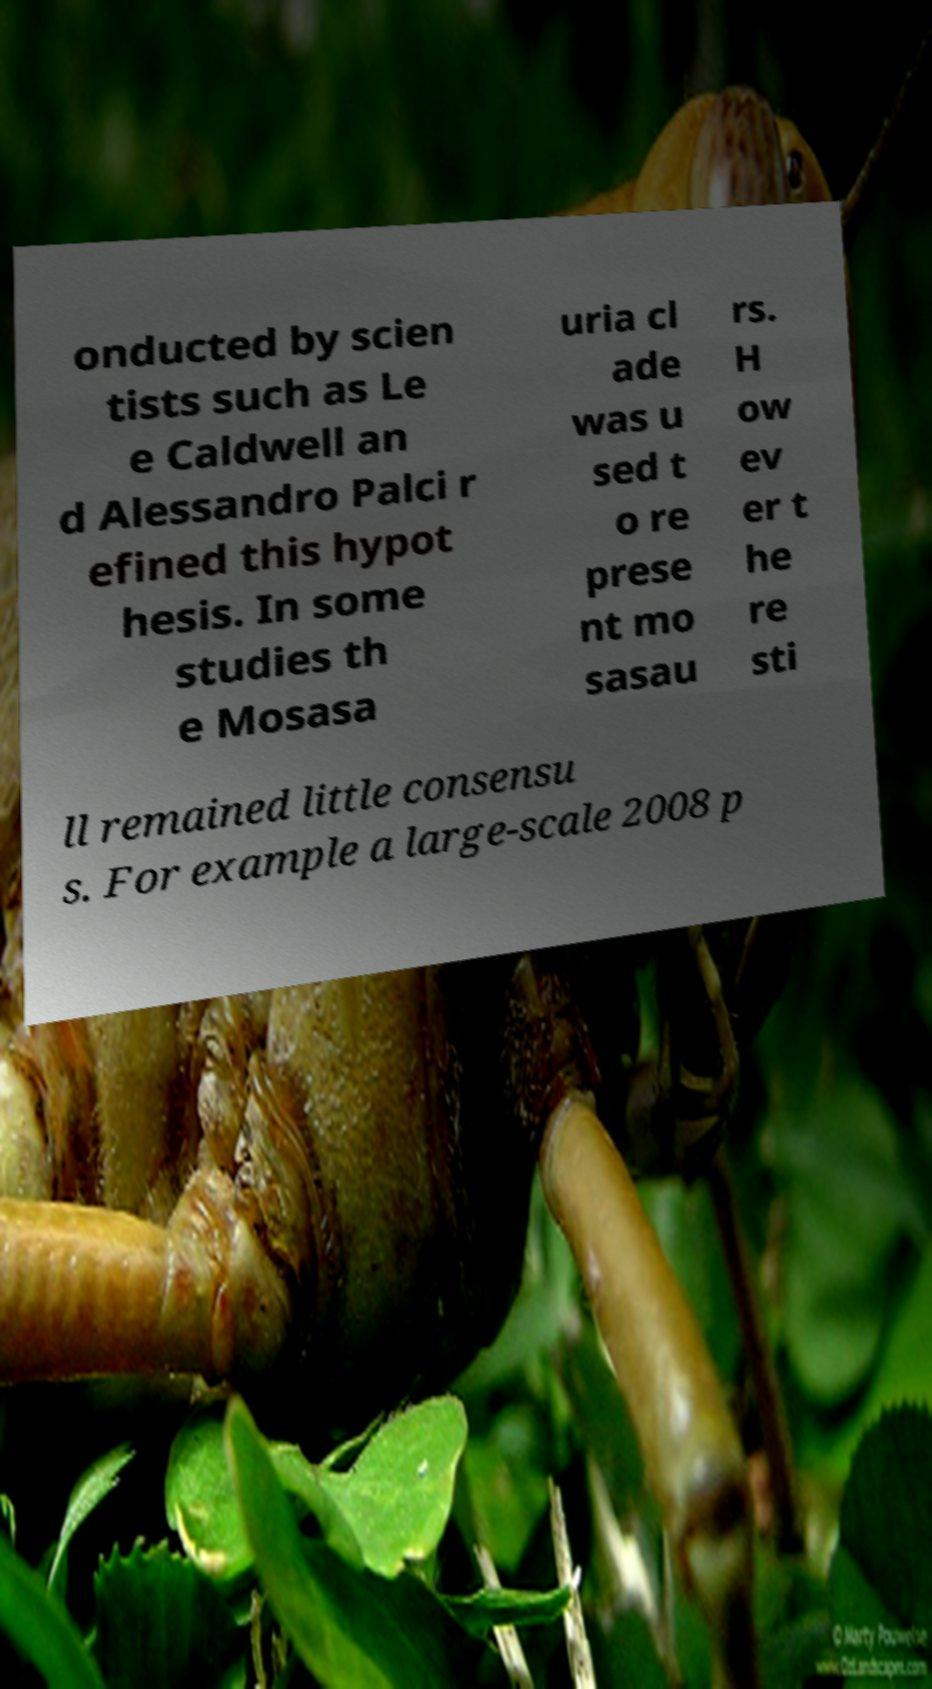There's text embedded in this image that I need extracted. Can you transcribe it verbatim? onducted by scien tists such as Le e Caldwell an d Alessandro Palci r efined this hypot hesis. In some studies th e Mosasa uria cl ade was u sed t o re prese nt mo sasau rs. H ow ev er t he re sti ll remained little consensu s. For example a large-scale 2008 p 